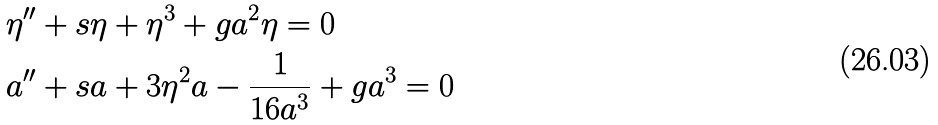Convert formula to latex. <formula><loc_0><loc_0><loc_500><loc_500>& \eta ^ { \prime \prime } + s \eta + \eta ^ { 3 } + g a ^ { 2 } \eta = 0 \\ & a ^ { \prime \prime } + s a + 3 \eta ^ { 2 } a - \frac { 1 } { 1 6 a ^ { 3 } } + g a ^ { 3 } = 0</formula> 